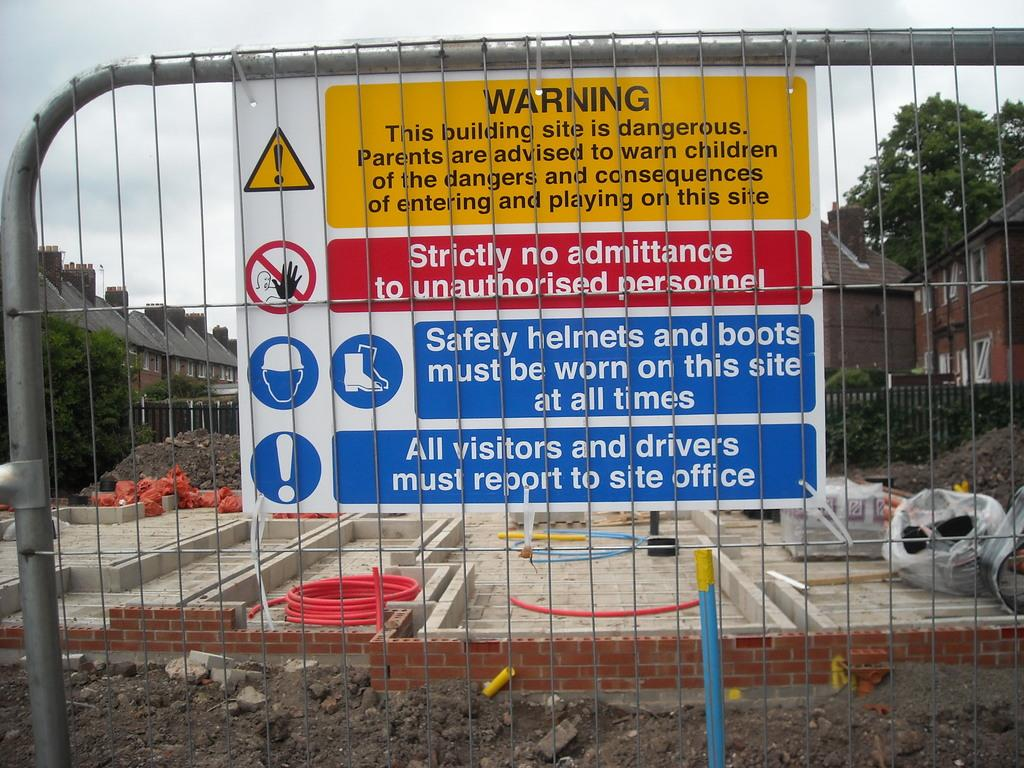<image>
Give a short and clear explanation of the subsequent image. A warning sign that sates that only authorised personnel can enter. 